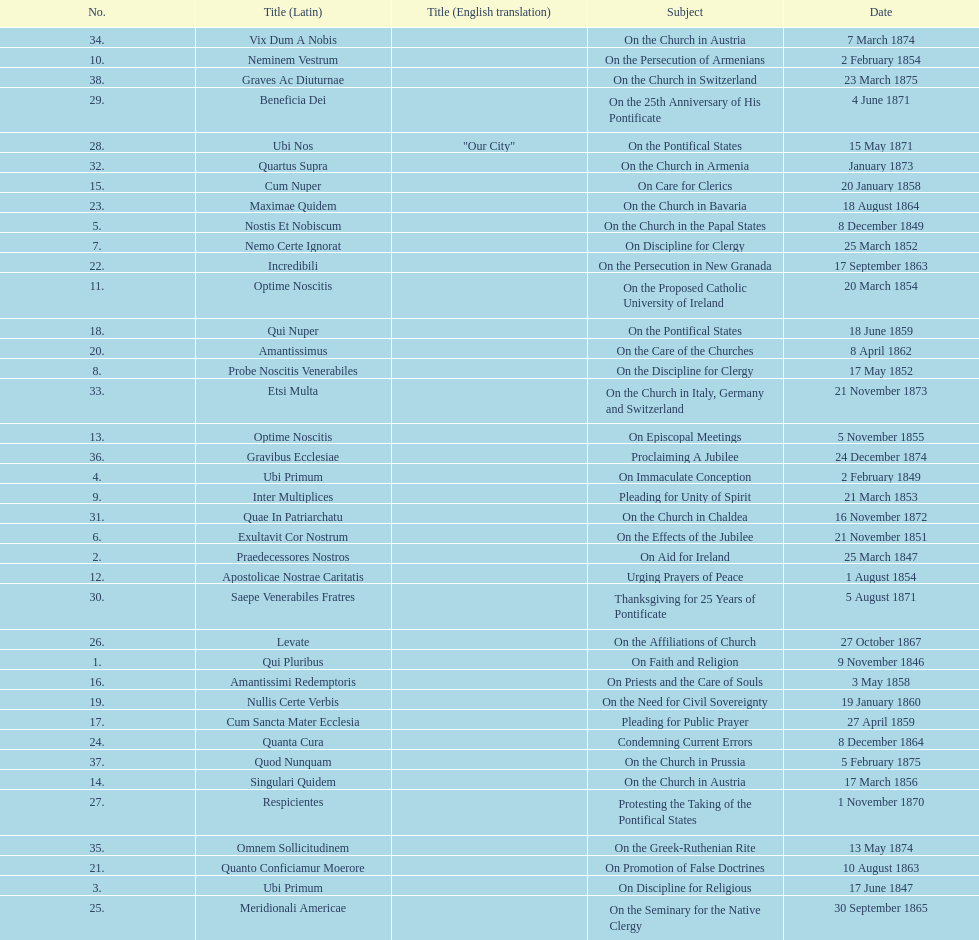Could you parse the entire table? {'header': ['No.', 'Title (Latin)', 'Title (English translation)', 'Subject', 'Date'], 'rows': [['34.', 'Vix Dum A Nobis', '', 'On the Church in Austria', '7 March 1874'], ['10.', 'Neminem Vestrum', '', 'On the Persecution of Armenians', '2 February 1854'], ['38.', 'Graves Ac Diuturnae', '', 'On the Church in Switzerland', '23 March 1875'], ['29.', 'Beneficia Dei', '', 'On the 25th Anniversary of His Pontificate', '4 June 1871'], ['28.', 'Ubi Nos', '"Our City"', 'On the Pontifical States', '15 May 1871'], ['32.', 'Quartus Supra', '', 'On the Church in Armenia', 'January 1873'], ['15.', 'Cum Nuper', '', 'On Care for Clerics', '20 January 1858'], ['23.', 'Maximae Quidem', '', 'On the Church in Bavaria', '18 August 1864'], ['5.', 'Nostis Et Nobiscum', '', 'On the Church in the Papal States', '8 December 1849'], ['7.', 'Nemo Certe Ignorat', '', 'On Discipline for Clergy', '25 March 1852'], ['22.', 'Incredibili', '', 'On the Persecution in New Granada', '17 September 1863'], ['11.', 'Optime Noscitis', '', 'On the Proposed Catholic University of Ireland', '20 March 1854'], ['18.', 'Qui Nuper', '', 'On the Pontifical States', '18 June 1859'], ['20.', 'Amantissimus', '', 'On the Care of the Churches', '8 April 1862'], ['8.', 'Probe Noscitis Venerabiles', '', 'On the Discipline for Clergy', '17 May 1852'], ['33.', 'Etsi Multa', '', 'On the Church in Italy, Germany and Switzerland', '21 November 1873'], ['13.', 'Optime Noscitis', '', 'On Episcopal Meetings', '5 November 1855'], ['36.', 'Gravibus Ecclesiae', '', 'Proclaiming A Jubilee', '24 December 1874'], ['4.', 'Ubi Primum', '', 'On Immaculate Conception', '2 February 1849'], ['9.', 'Inter Multiplices', '', 'Pleading for Unity of Spirit', '21 March 1853'], ['31.', 'Quae In Patriarchatu', '', 'On the Church in Chaldea', '16 November 1872'], ['6.', 'Exultavit Cor Nostrum', '', 'On the Effects of the Jubilee', '21 November 1851'], ['2.', 'Praedecessores Nostros', '', 'On Aid for Ireland', '25 March 1847'], ['12.', 'Apostolicae Nostrae Caritatis', '', 'Urging Prayers of Peace', '1 August 1854'], ['30.', 'Saepe Venerabiles Fratres', '', 'Thanksgiving for 25 Years of Pontificate', '5 August 1871'], ['26.', 'Levate', '', 'On the Affiliations of Church', '27 October 1867'], ['1.', 'Qui Pluribus', '', 'On Faith and Religion', '9 November 1846'], ['16.', 'Amantissimi Redemptoris', '', 'On Priests and the Care of Souls', '3 May 1858'], ['19.', 'Nullis Certe Verbis', '', 'On the Need for Civil Sovereignty', '19 January 1860'], ['17.', 'Cum Sancta Mater Ecclesia', '', 'Pleading for Public Prayer', '27 April 1859'], ['24.', 'Quanta Cura', '', 'Condemning Current Errors', '8 December 1864'], ['37.', 'Quod Nunquam', '', 'On the Church in Prussia', '5 February 1875'], ['14.', 'Singulari Quidem', '', 'On the Church in Austria', '17 March 1856'], ['27.', 'Respicientes', '', 'Protesting the Taking of the Pontifical States', '1 November 1870'], ['35.', 'Omnem Sollicitudinem', '', 'On the Greek-Ruthenian Rite', '13 May 1874'], ['21.', 'Quanto Conficiamur Moerore', '', 'On Promotion of False Doctrines', '10 August 1863'], ['3.', 'Ubi Primum', '', 'On Discipline for Religious', '17 June 1847'], ['25.', 'Meridionali Americae', '', 'On the Seminary for the Native Clergy', '30 September 1865']]} How often was an encyclical sent in january? 3. 